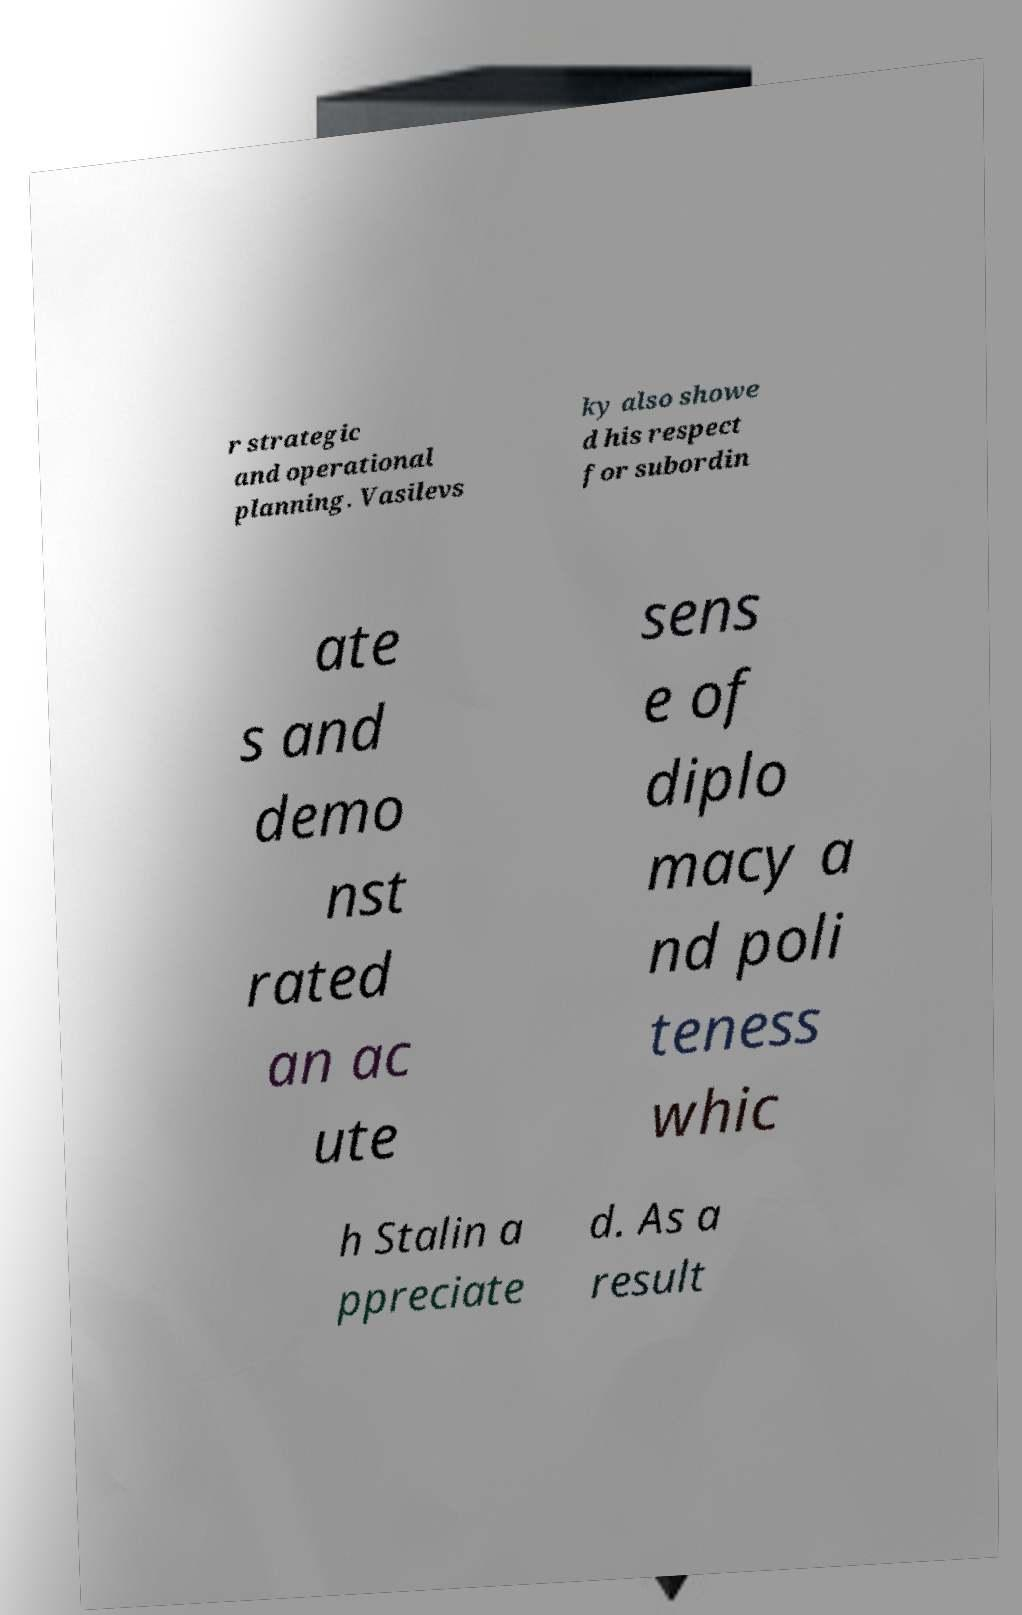What messages or text are displayed in this image? I need them in a readable, typed format. r strategic and operational planning. Vasilevs ky also showe d his respect for subordin ate s and demo nst rated an ac ute sens e of diplo macy a nd poli teness whic h Stalin a ppreciate d. As a result 